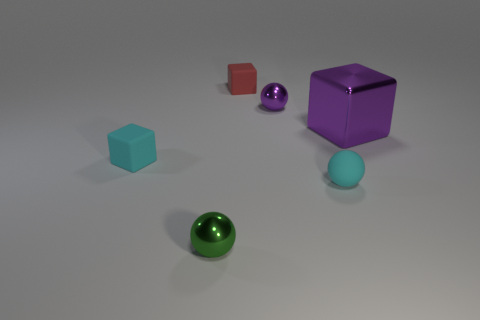Add 3 purple things. How many objects exist? 9 Subtract 1 green spheres. How many objects are left? 5 Subtract all purple spheres. Subtract all tiny matte balls. How many objects are left? 4 Add 1 green things. How many green things are left? 2 Add 6 purple metallic spheres. How many purple metallic spheres exist? 7 